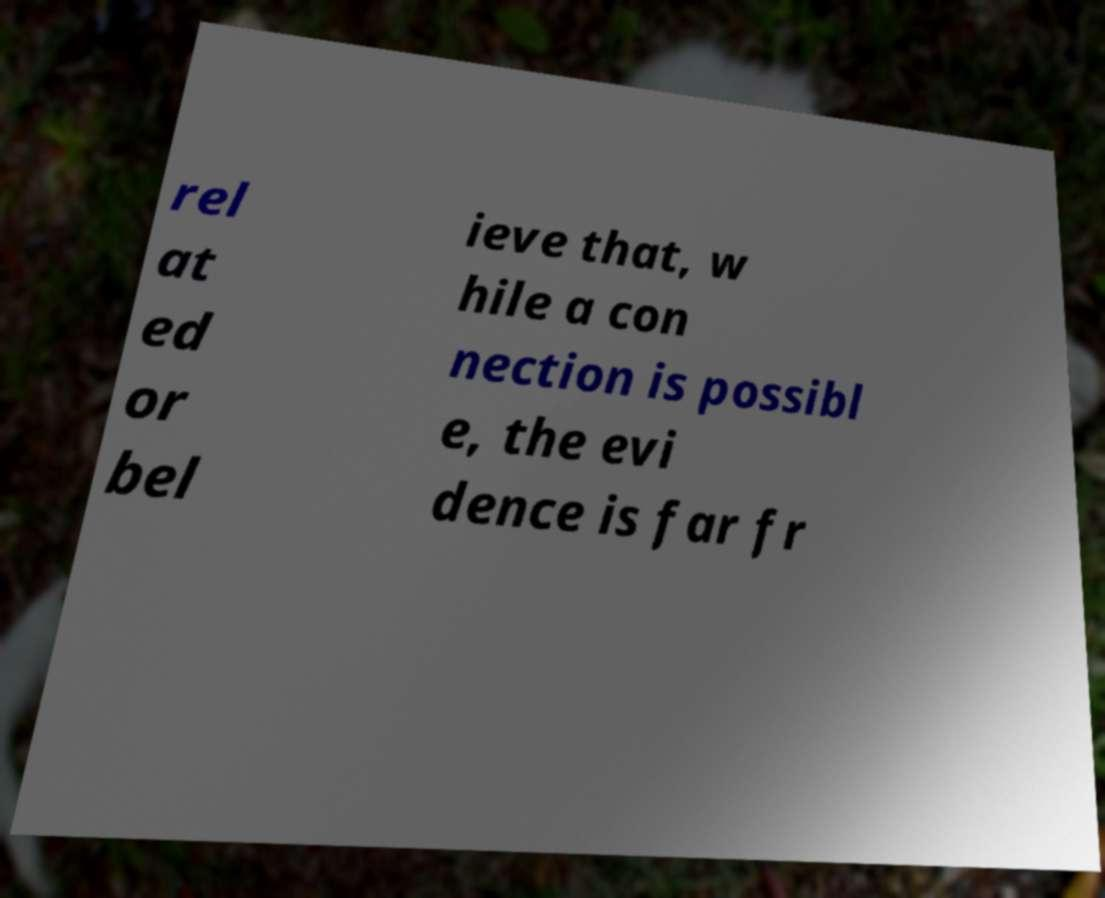Can you read and provide the text displayed in the image?This photo seems to have some interesting text. Can you extract and type it out for me? rel at ed or bel ieve that, w hile a con nection is possibl e, the evi dence is far fr 